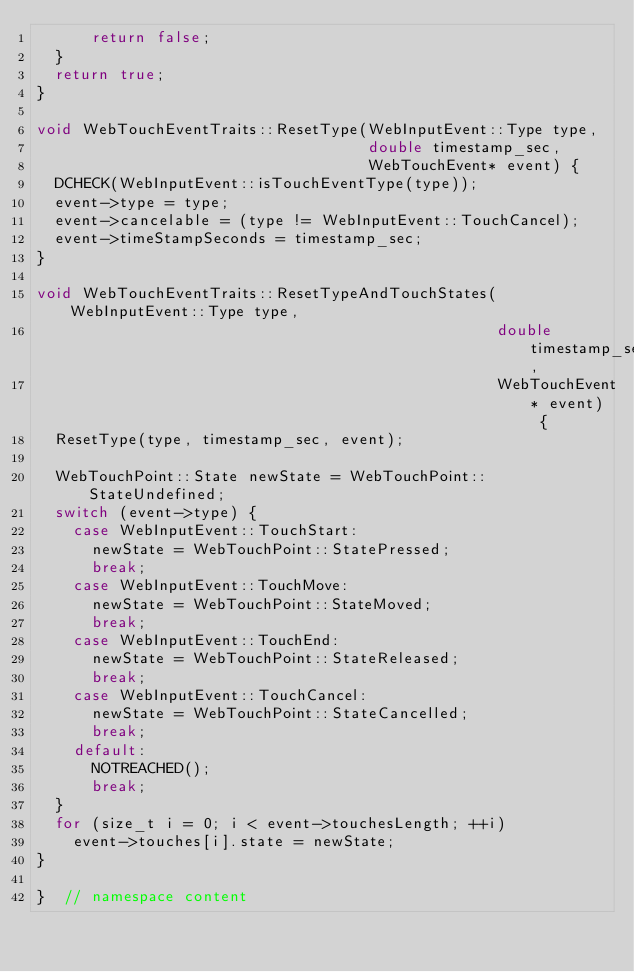Convert code to text. <code><loc_0><loc_0><loc_500><loc_500><_C++_>      return false;
  }
  return true;
}

void WebTouchEventTraits::ResetType(WebInputEvent::Type type,
                                    double timestamp_sec,
                                    WebTouchEvent* event) {
  DCHECK(WebInputEvent::isTouchEventType(type));
  event->type = type;
  event->cancelable = (type != WebInputEvent::TouchCancel);
  event->timeStampSeconds = timestamp_sec;
}

void WebTouchEventTraits::ResetTypeAndTouchStates(WebInputEvent::Type type,
                                                  double timestamp_sec,
                                                  WebTouchEvent* event) {
  ResetType(type, timestamp_sec, event);

  WebTouchPoint::State newState = WebTouchPoint::StateUndefined;
  switch (event->type) {
    case WebInputEvent::TouchStart:
      newState = WebTouchPoint::StatePressed;
      break;
    case WebInputEvent::TouchMove:
      newState = WebTouchPoint::StateMoved;
      break;
    case WebInputEvent::TouchEnd:
      newState = WebTouchPoint::StateReleased;
      break;
    case WebInputEvent::TouchCancel:
      newState = WebTouchPoint::StateCancelled;
      break;
    default:
      NOTREACHED();
      break;
  }
  for (size_t i = 0; i < event->touchesLength; ++i)
    event->touches[i].state = newState;
}

}  // namespace content
</code> 